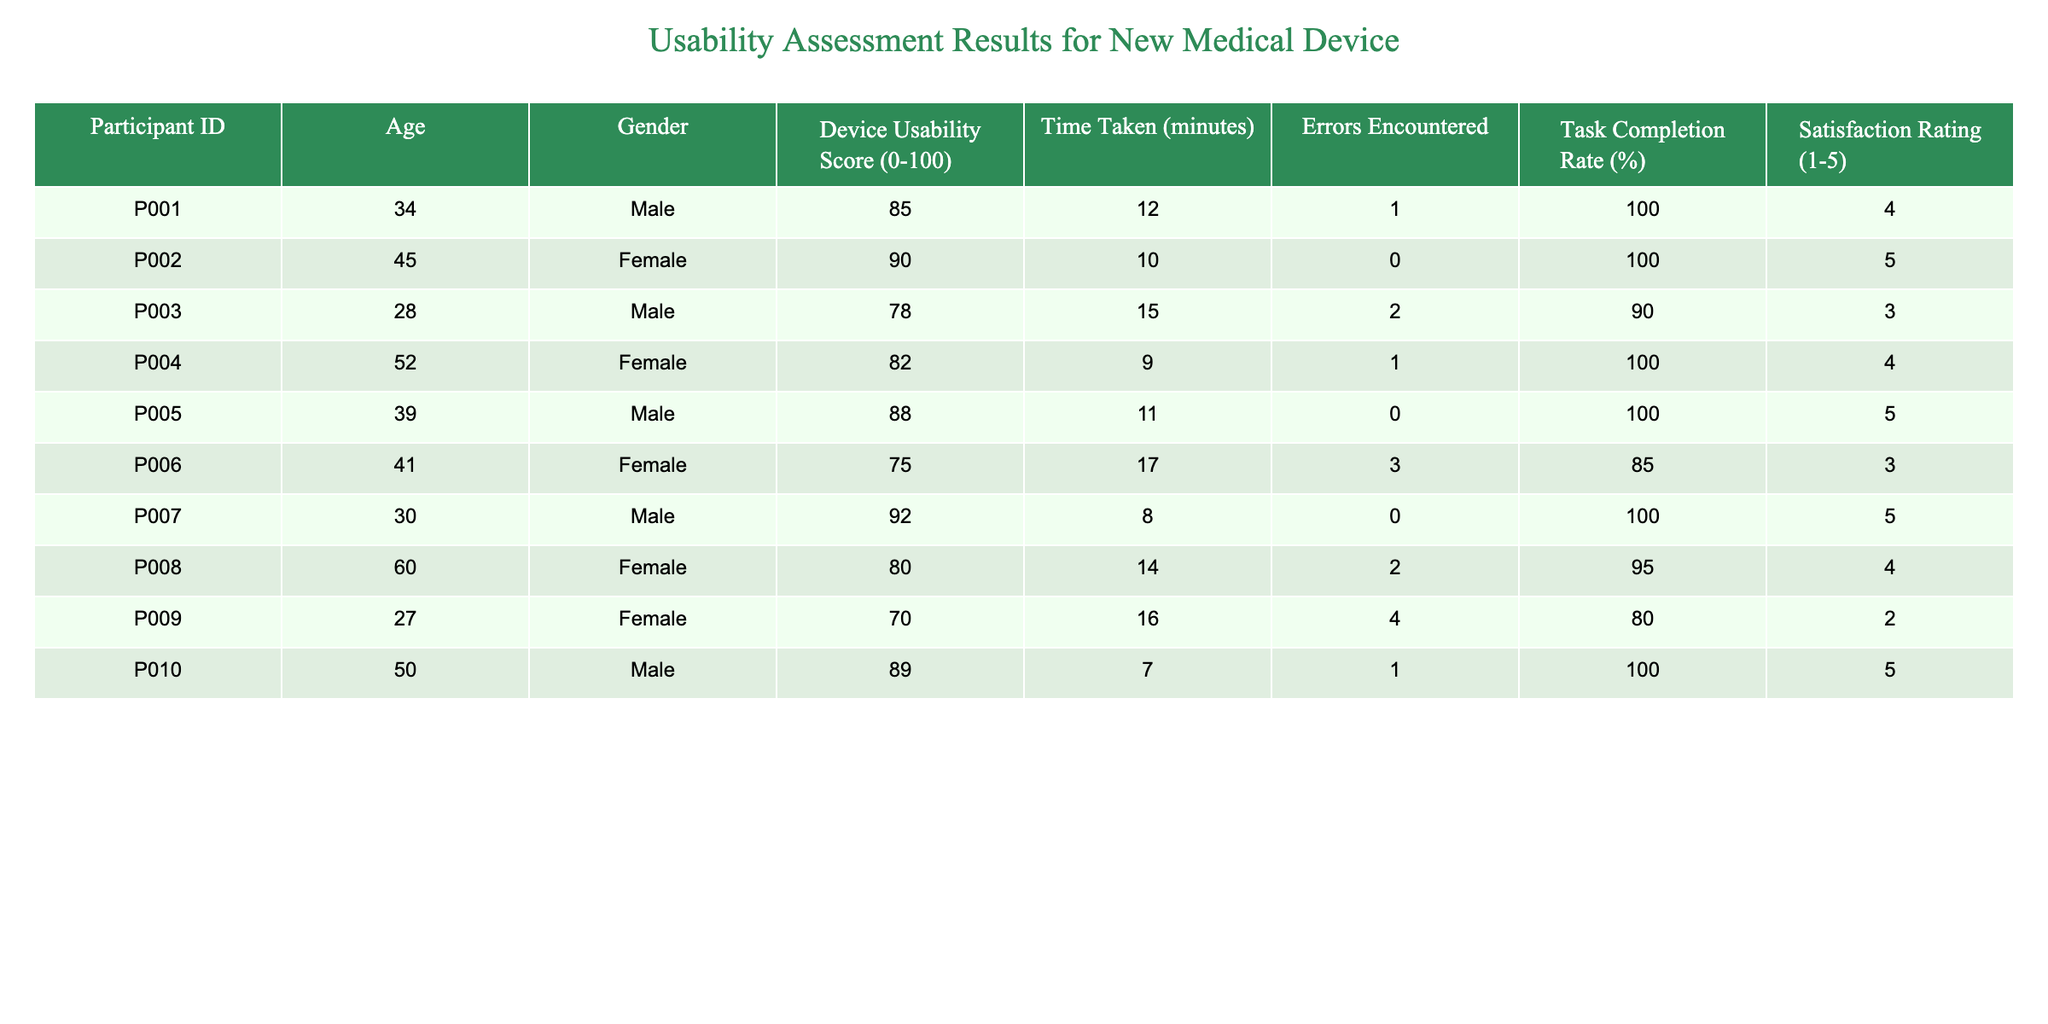What is the Device Usability Score of Participant P005? The Device Usability Score for Participant P005 is directly listed in the table, which shows a score of 88.
Answer: 88 What is the average time taken by all participants to complete the task? The times taken by all participants are 12, 10, 15, 9, 11, 17, 8, 14, 16, and 7 minutes. Adding these gives 119 minutes, and dividing by the number of participants (10) gives 119/10 = 11.9.
Answer: 11.9 Did any participant encounter more than 3 errors? Checking the "Errors Encountered" column, the maximum is 4 (Participant P009). Since no participant has more than this, the answer is yes.
Answer: Yes What is the Task Completion Rate for participants aged 60 and older? Only Participant P008 is aged 60, and their Task Completion Rate is 95%. Therefore, no averaging is needed.
Answer: 95 Which participant had the highest Satisfaction Rating? By reviewing the "Satisfaction Rating" column, P002 had a score of 5, which is the highest.
Answer: P002 What is the median Device Usability Score among the participants? To find the median, first list the scores in order: 70, 75, 78, 80, 82, 85, 88, 89, 90, 92. The median is the average of the two middle scores (82 and 85), which is (82 + 85) / 2 = 83.5.
Answer: 83.5 Is there any correlation between the Age of participants and their Device Usability Score? Although this requires some analysis, a quick glance shows no obvious correlation since scores vary independently of age. Thus, the answer is no without performing detailed calculations.
Answer: No How many participants achieved a Device Usability Score greater than 85? Participants P002, P005, P007, P010 all scored over 85, totaling four participants.
Answer: 4 What is the average Satisfaction Rating of participants who encountered errors? Participants who encountered errors (P003, P006, and P009) have ratings of 3, 3, and 2. Summing these gives 8, and averaging them (8/3) results in approximately 2.67.
Answer: 2.67 